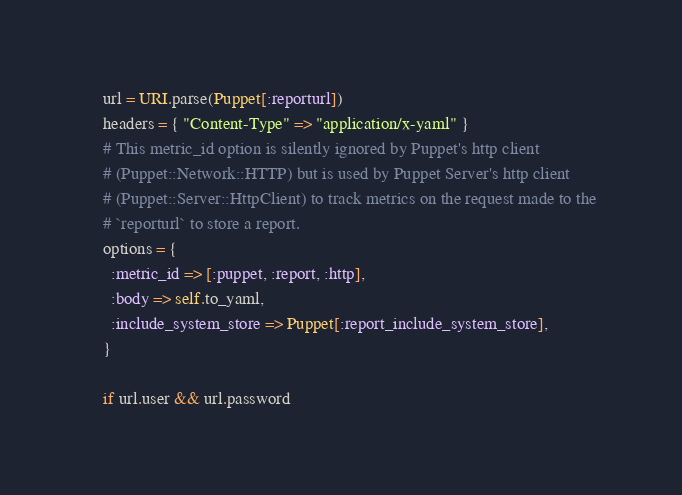<code> <loc_0><loc_0><loc_500><loc_500><_Ruby_>    url = URI.parse(Puppet[:reporturl])
    headers = { "Content-Type" => "application/x-yaml" }
    # This metric_id option is silently ignored by Puppet's http client
    # (Puppet::Network::HTTP) but is used by Puppet Server's http client
    # (Puppet::Server::HttpClient) to track metrics on the request made to the
    # `reporturl` to store a report.
    options = {
      :metric_id => [:puppet, :report, :http],
      :body => self.to_yaml,
      :include_system_store => Puppet[:report_include_system_store],
    }

    if url.user && url.password</code> 